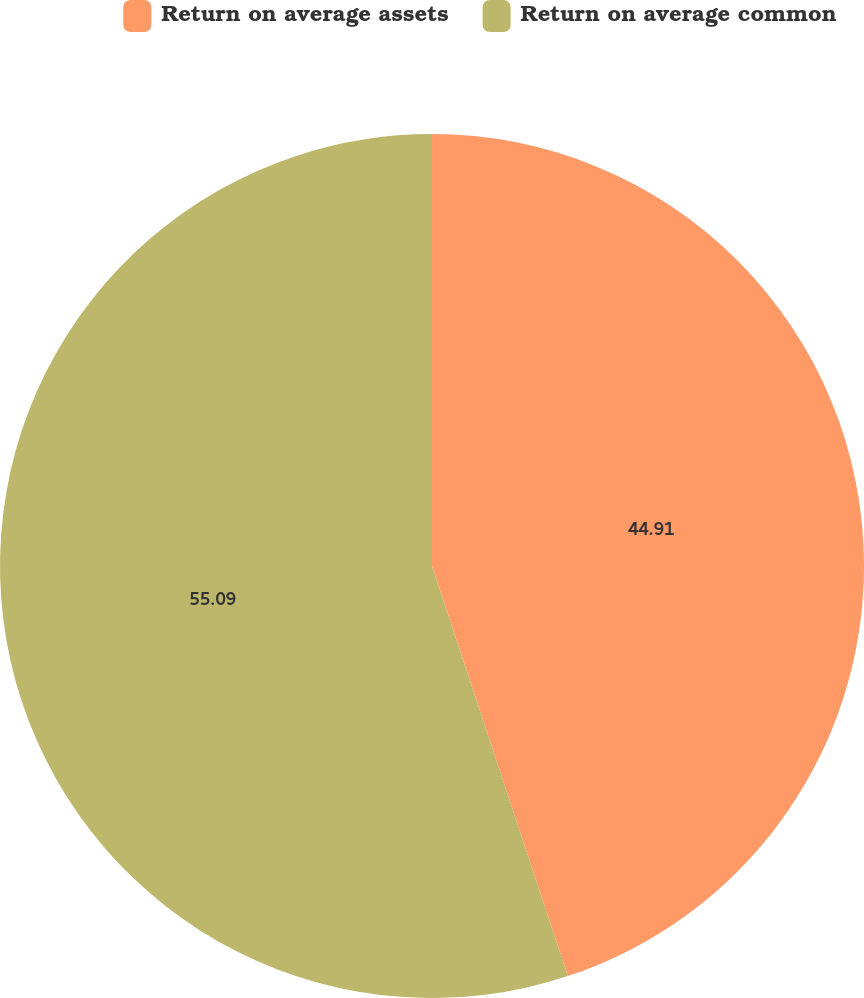Convert chart. <chart><loc_0><loc_0><loc_500><loc_500><pie_chart><fcel>Return on average assets<fcel>Return on average common<nl><fcel>44.91%<fcel>55.09%<nl></chart> 